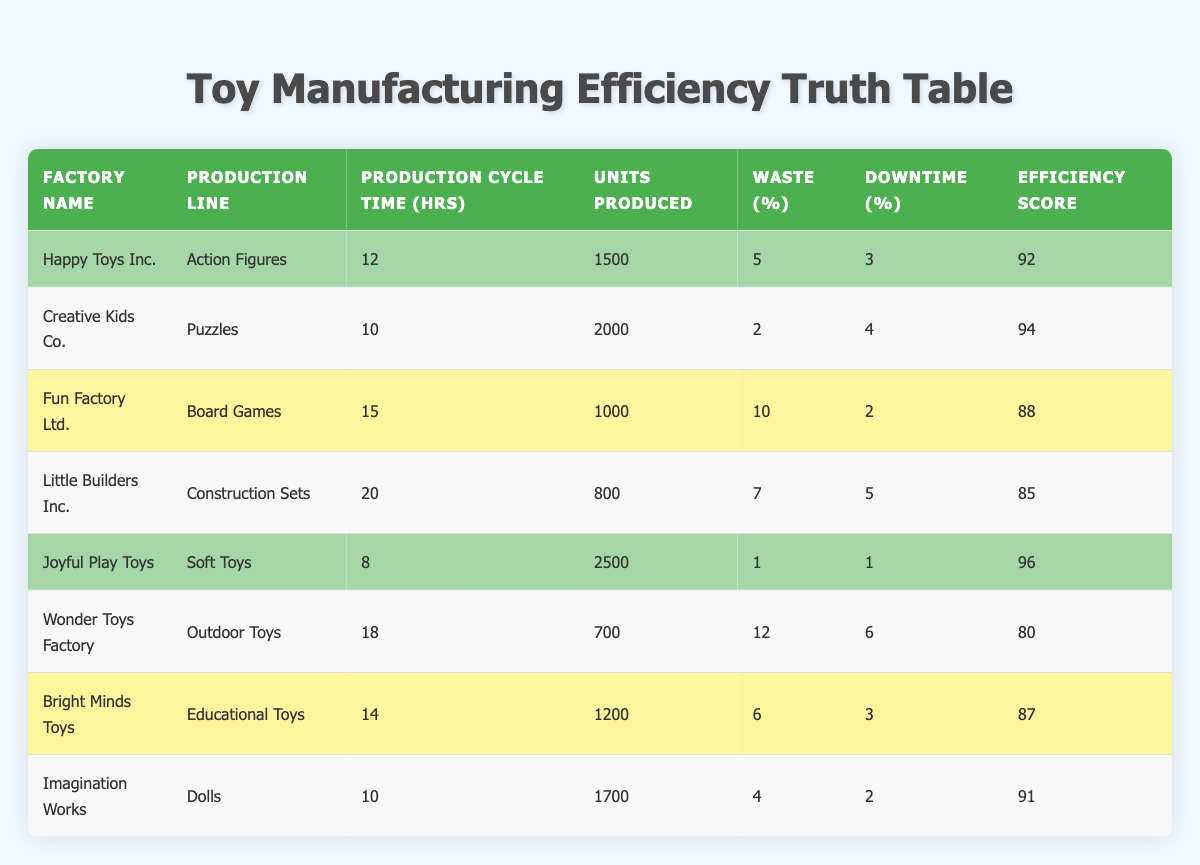What is the factory with the highest efficiency score? Looking through the table, "Joyful Play Toys" has the highest efficiency score of 96.
Answer: Joyful Play Toys What is the production cycle time for "Imagination Works"? In the table, the production cycle time for "Imagination Works" is listed as 10 hours.
Answer: 10 hours Which factory produces the least number of units? By examining the "Units Produced" column, "Wonder Toys Factory" produces the least at 700 units.
Answer: Wonder Toys Factory What is the average waste percentage across all factories? To find the average waste percentage, sum the waste percentages: (5 + 2 + 10 + 7 + 1 + 12 + 6 + 4) = 47 and then divide by the number of factories (8), resulting in an average of 47/8 = 5.875.
Answer: 5.875 Is "Creative Kids Co." more efficient than "Fun Factory Ltd."? Comparing the efficiency scores, "Creative Kids Co." has a score of 94 while "Fun Factory Ltd." has 88. Hence, "Creative Kids Co." is more efficient.
Answer: Yes What is the total number of units produced by factories with efficiency scores greater than 90? The factories with efficiency scores greater than 90 are "Joyful Play Toys" (2500 units), "Creative Kids Co." (2000 units), "Happy Toys Inc." (1500 units), and "Imagination Works" (1700 units). Adding these gives: 2500 + 2000 + 1500 + 1700 = 7700 units produced in total.
Answer: 7700 units Which production line has the longest production cycle time? The production cycle time is highest at "Little Builders Inc." with 20 hours for "Construction Sets".
Answer: Construction Sets How many factories have a waste percentage less than 5%? Checking the waste percentages, only "Joyful Play Toys" (1%) and "Creative Kids Co." (2%) have waste percentages less than 5%, making a total of 2 factories.
Answer: 2 factories Is the downtime percentage for "Wonder Toys Factory" greater than 5%? The downtime percentage for "Wonder Toys Factory" is 6%, which is indeed greater than 5%.
Answer: Yes 